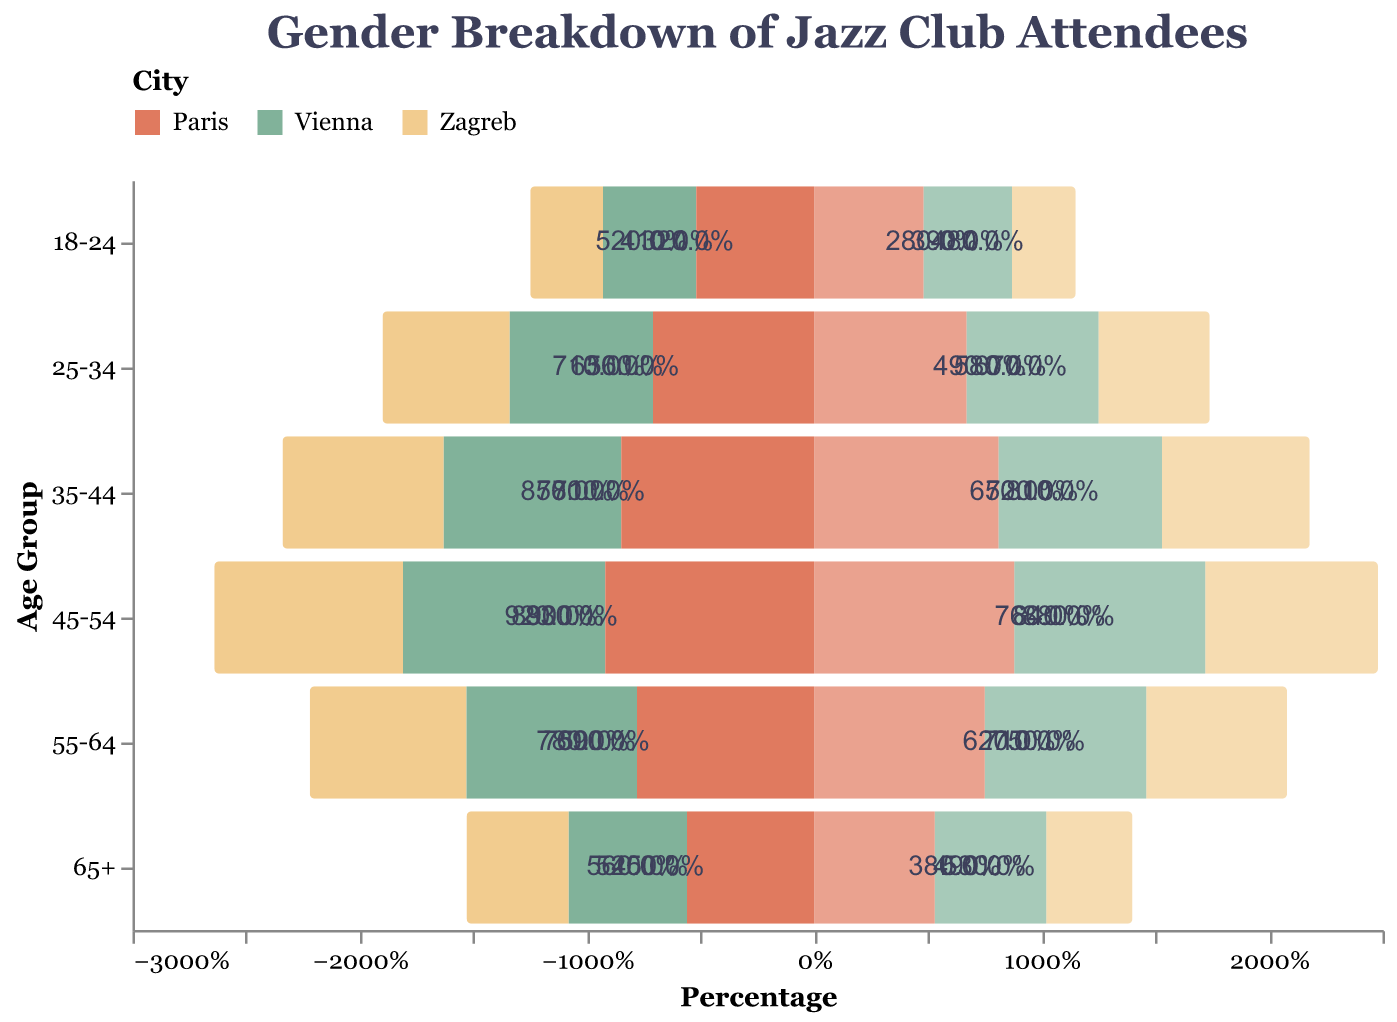What is the age group with the highest percentage of male attendees in Zagreb? Refer to the values presented for each age group for Male Zagreb. The highest percentage is in the age group 45-54 with 8.3%.
Answer: 45-54 Which city has a higher percentage of female attendees in the 25-34 age group, Zagreb or Vienna? Compare the percentages of Female Zagreb (4.9) and Female Vienna (5.8) in the 25-34 age group. Vienna has a higher percentage.
Answer: Vienna Among attendees aged 35-44, which gender in Paris has a higher percentage? Compare the percentages of Male Paris (8.5) and Female Paris (8.1) in the 35-44 age group. Males have a higher percentage.
Answer: Male What is the combined percentage of attendees in the 55-64 age group in Zagreb (both genders)? Add the percentages for Male Zagreb (6.9) and Female Zagreb (6.2). The combined percentage is 13.1%.
Answer: 13.1% How does the percentage of male attendees aged 65+ in Paris compare to Vienna? Compare the percentages of Male Paris (5.6) and Male Vienna (5.2) in the 65+ age group. Paris has a higher percentage.
Answer: Higher What is the percentage difference between male and female attendees in the 45-54 age group in Zagreb? Subtract the percentage of Female Zagreb (7.6) from Male Zagreb (8.3) for the 45-54 age group. The difference is 0.7%.
Answer: 0.7% Between ages 18-24, which city has the highest percentage of male attendees? Compare the percentages of Male Zagreb (3.2), Male Vienna (4.1), and Male Paris (5.2) in the 18-24 age group. Paris has the highest percentage.
Answer: Paris Which age group in Paris shows the least gender disparity in percentages? To identify the age group with the least gender disparity, calculate the difference between Male and Female Paris for each age group. The smallest difference (0.3%) is in the 55-64 age group.
Answer: 55-64 What trend do you notice in the percentage of male attendees in Zagreb as age increases? Observe the percentages of Male Zagreb across all age groups: 3.2 (18-24), 5.6 (25-34), 7.1 (35-44), 8.3 (45-54), 6.9 (55-64), 4.5 (65+). The percentage generally increases until 45-54 and then decreases.
Answer: Increases until 45-54, then decreases How does the percentage of female attendees aged 35-44 in Vienna compare to Paris? Compare the percentages of Female Vienna (7.2) and Female Paris (8.1) in the 35-44 age group. Paris has a higher percentage.
Answer: Paris 